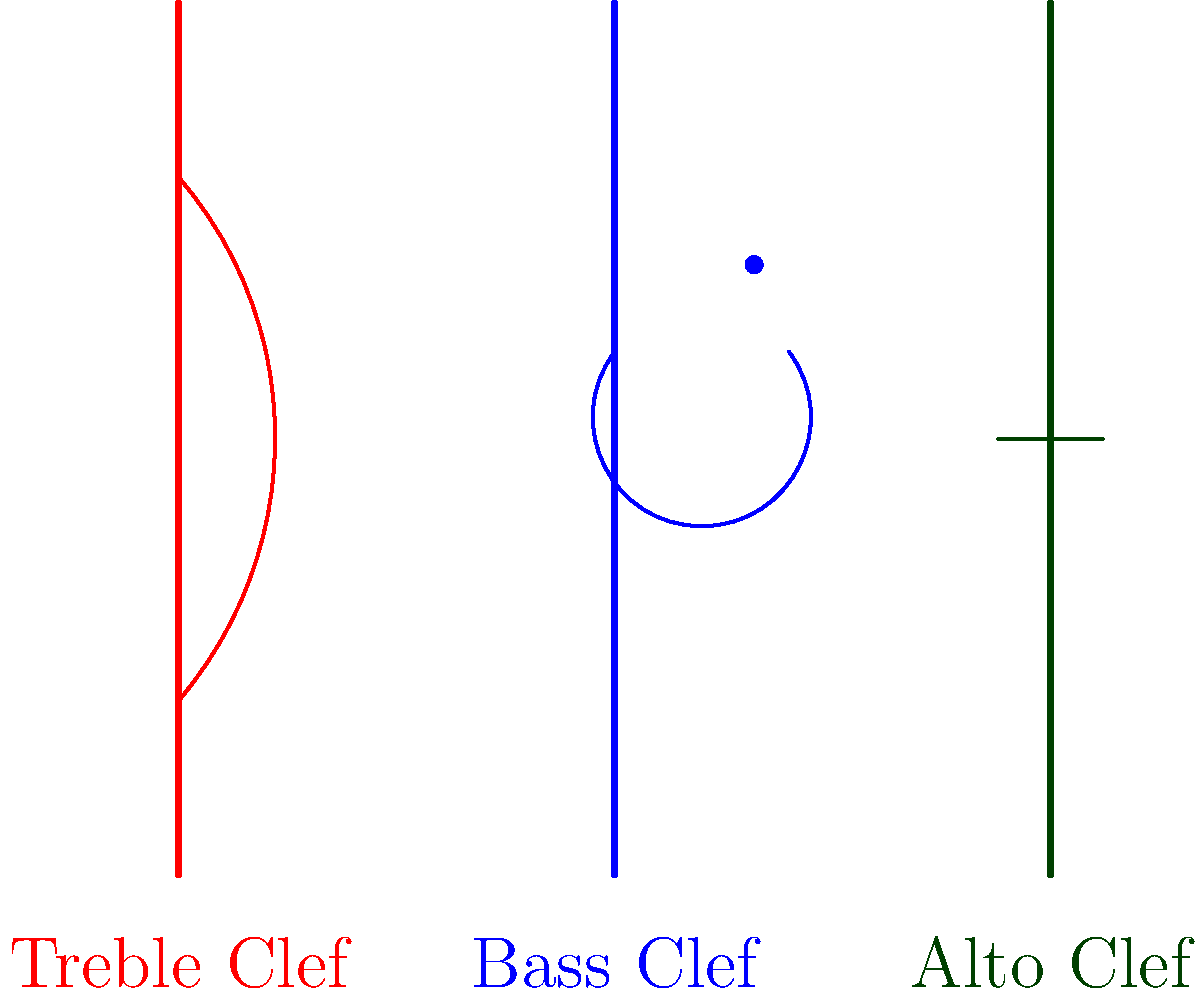Identify the clef that is typically used for viola parts in an orchestra score. To answer this question, let's analyze each clef presented in the image:

1. Treble Clef (Red):
   - This clef is commonly used for higher-pitched instruments like violin, flute, and the right hand of piano parts.
   - It's not typically used for viola parts.

2. Bass Clef (Blue):
   - This clef is used for lower-pitched instruments like cello, double bass, and the left hand of piano parts.
   - It's also not typically used for viola parts.

3. Alto Clef (Green):
   - This clef is specifically designed for mid-range instruments.
   - The viola, being a mid-range instrument in the string family, typically uses this clef.
   - The alto clef places the middle C on the middle line of the staff, which is ideal for the viola's range.

Therefore, the clef typically used for viola parts in an orchestra score is the Alto Clef.
Answer: Alto Clef 